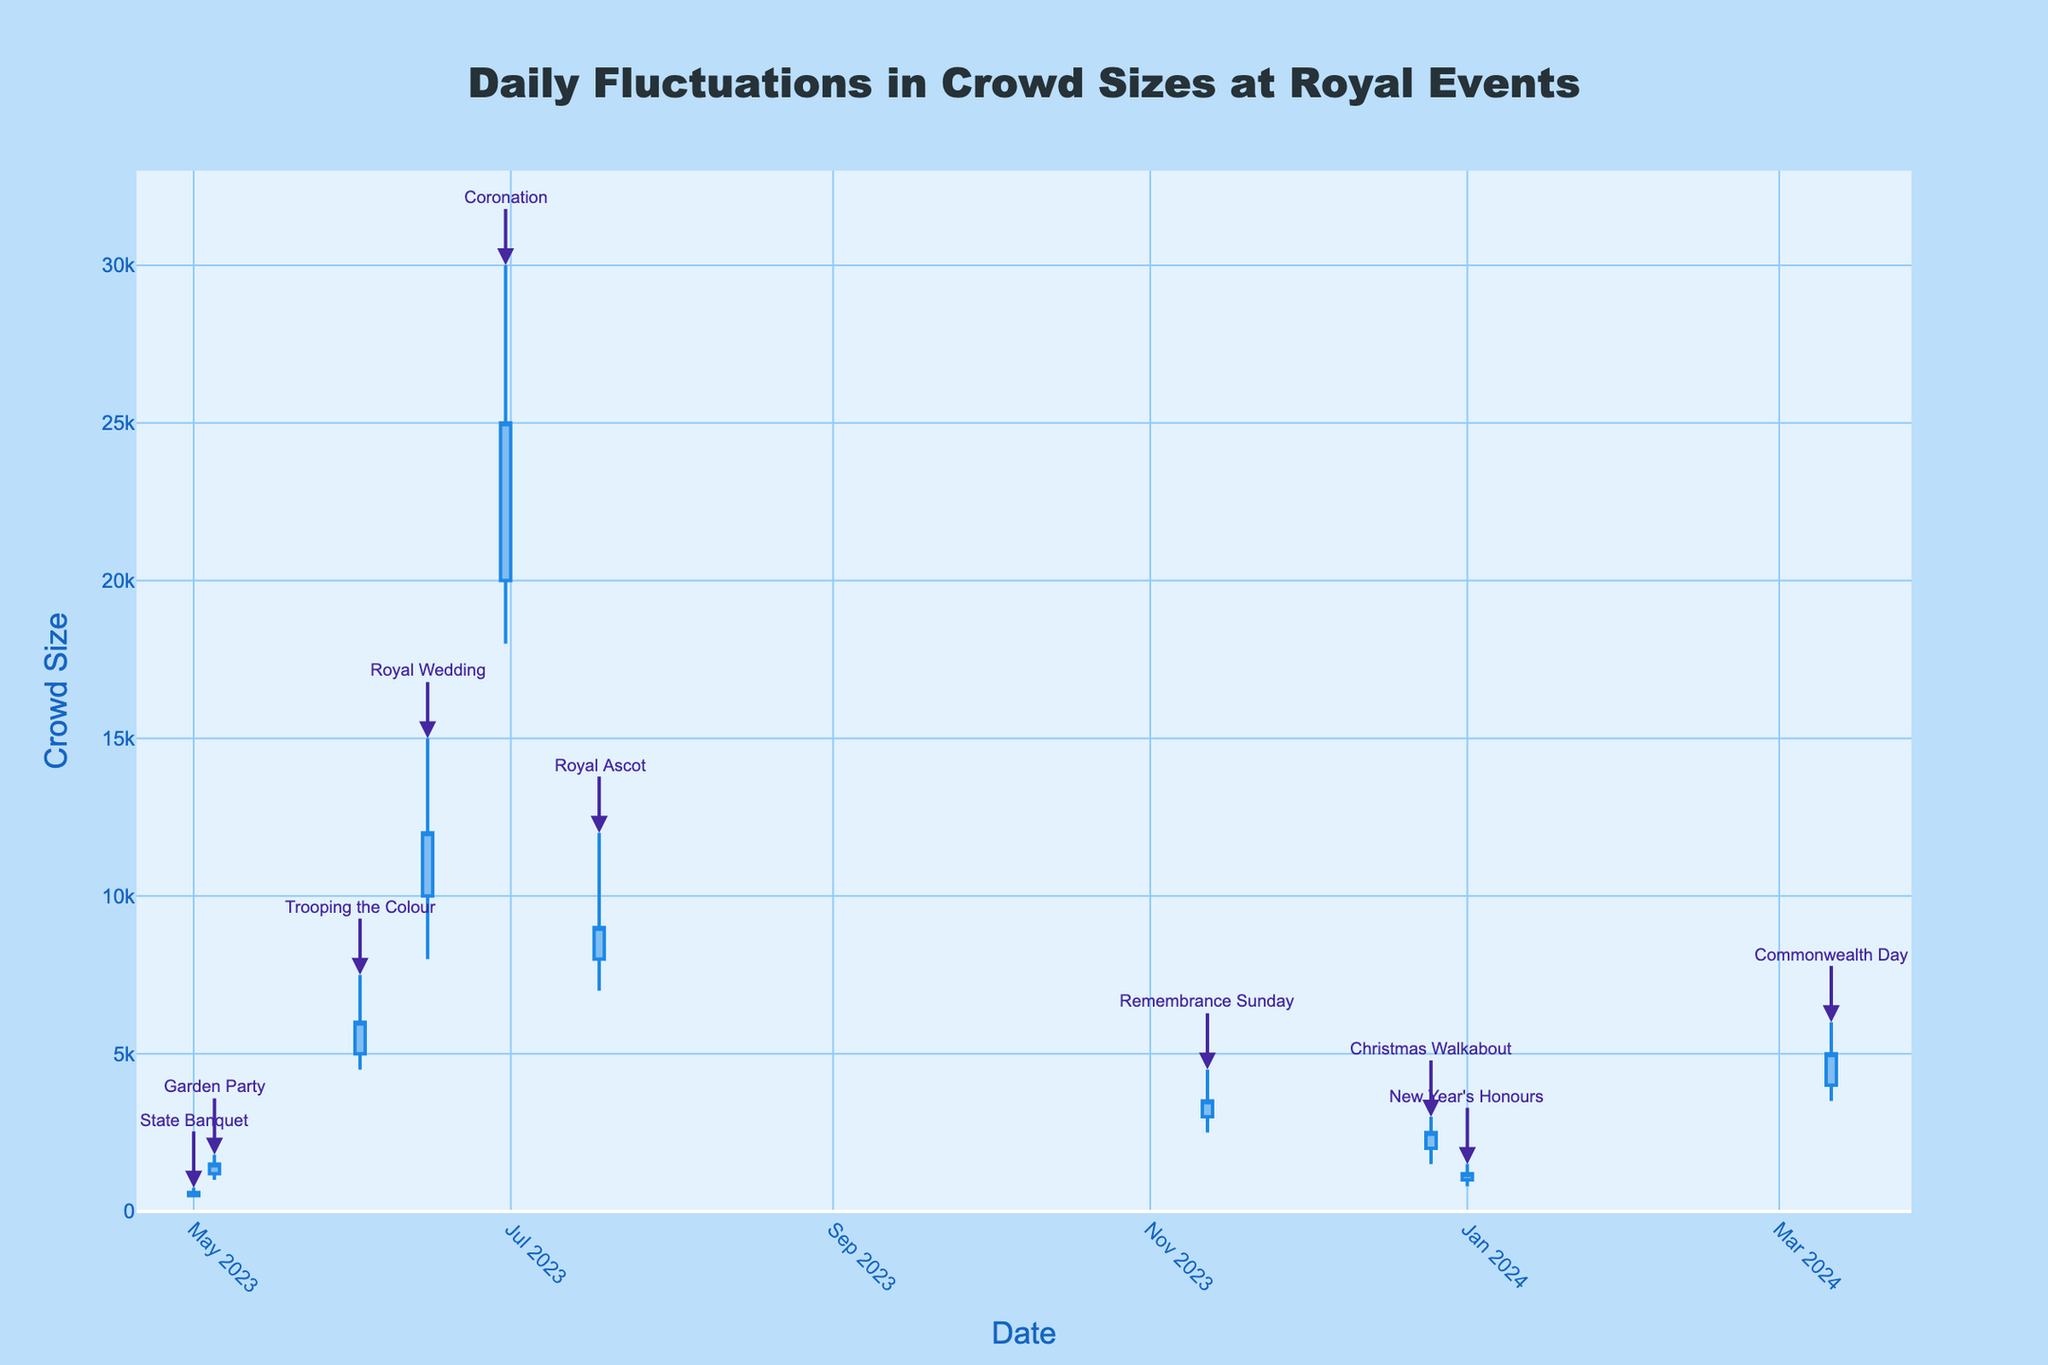what is the title of the figure? The title is displayed at the top of the figure, centered, and reads "Daily Fluctuations in Crowd Sizes at Royal Events"
Answer: Daily Fluctuations in Crowd Sizes at Royal Events What is the highest recorded crowd size, and which event does it correspond to? Find the highest value on the y-axis, which is 30000, and check the event annotation at the same position. The annotation reads "Coronation."
Answer: Coronation Which event had the lowest closing crowd size, and what was the value? Examine the `close` values; the lowest close is 600, which corresponds to the "State Banquet" on May 1, 2023
Answer: State Banquet, 600 Which month had the highest average crowd size? For each month, calculate the average of (open + high + low + close) / 4 across all events in that month and compare. June has the highest average considering "Trooping the Colour," "Royal Wedding," and "Coronation."
Answer: June What is the trend of crowd sizes over time from May 2023 to January 2024? Observe the overall pattern of the OHLC chart from left to right. Initially, crowd sizes increase, peaking in June, dipping afterward, with smaller fluctuations towards January 2024.
Answer: Increasing then decreasing Which event saw the largest intra-day fluctuation in crowd size, and what was the difference? Intra-day fluctuation is given by (high - low). The "Coronation" had a high of 30000 and a low of 18000. The difference is 12000.
Answer: Coronation, 12000 How many events had a closing crowd size higher than their opening crowd size? Compare the `close` and `open` values for each event. There are five such events: "Garden Party," "Trooping the Colour," "Royal Wedding," "Coronation," and "Christmas Walkabout."
Answer: 5 Which event in November had the highest crowd size recorded, and what was the value? Filter for November events, examine the `high` values. Only "Remembrance Sunday" is in November, with a high of 4500.
Answer: Remembrance Sunday, 4500 